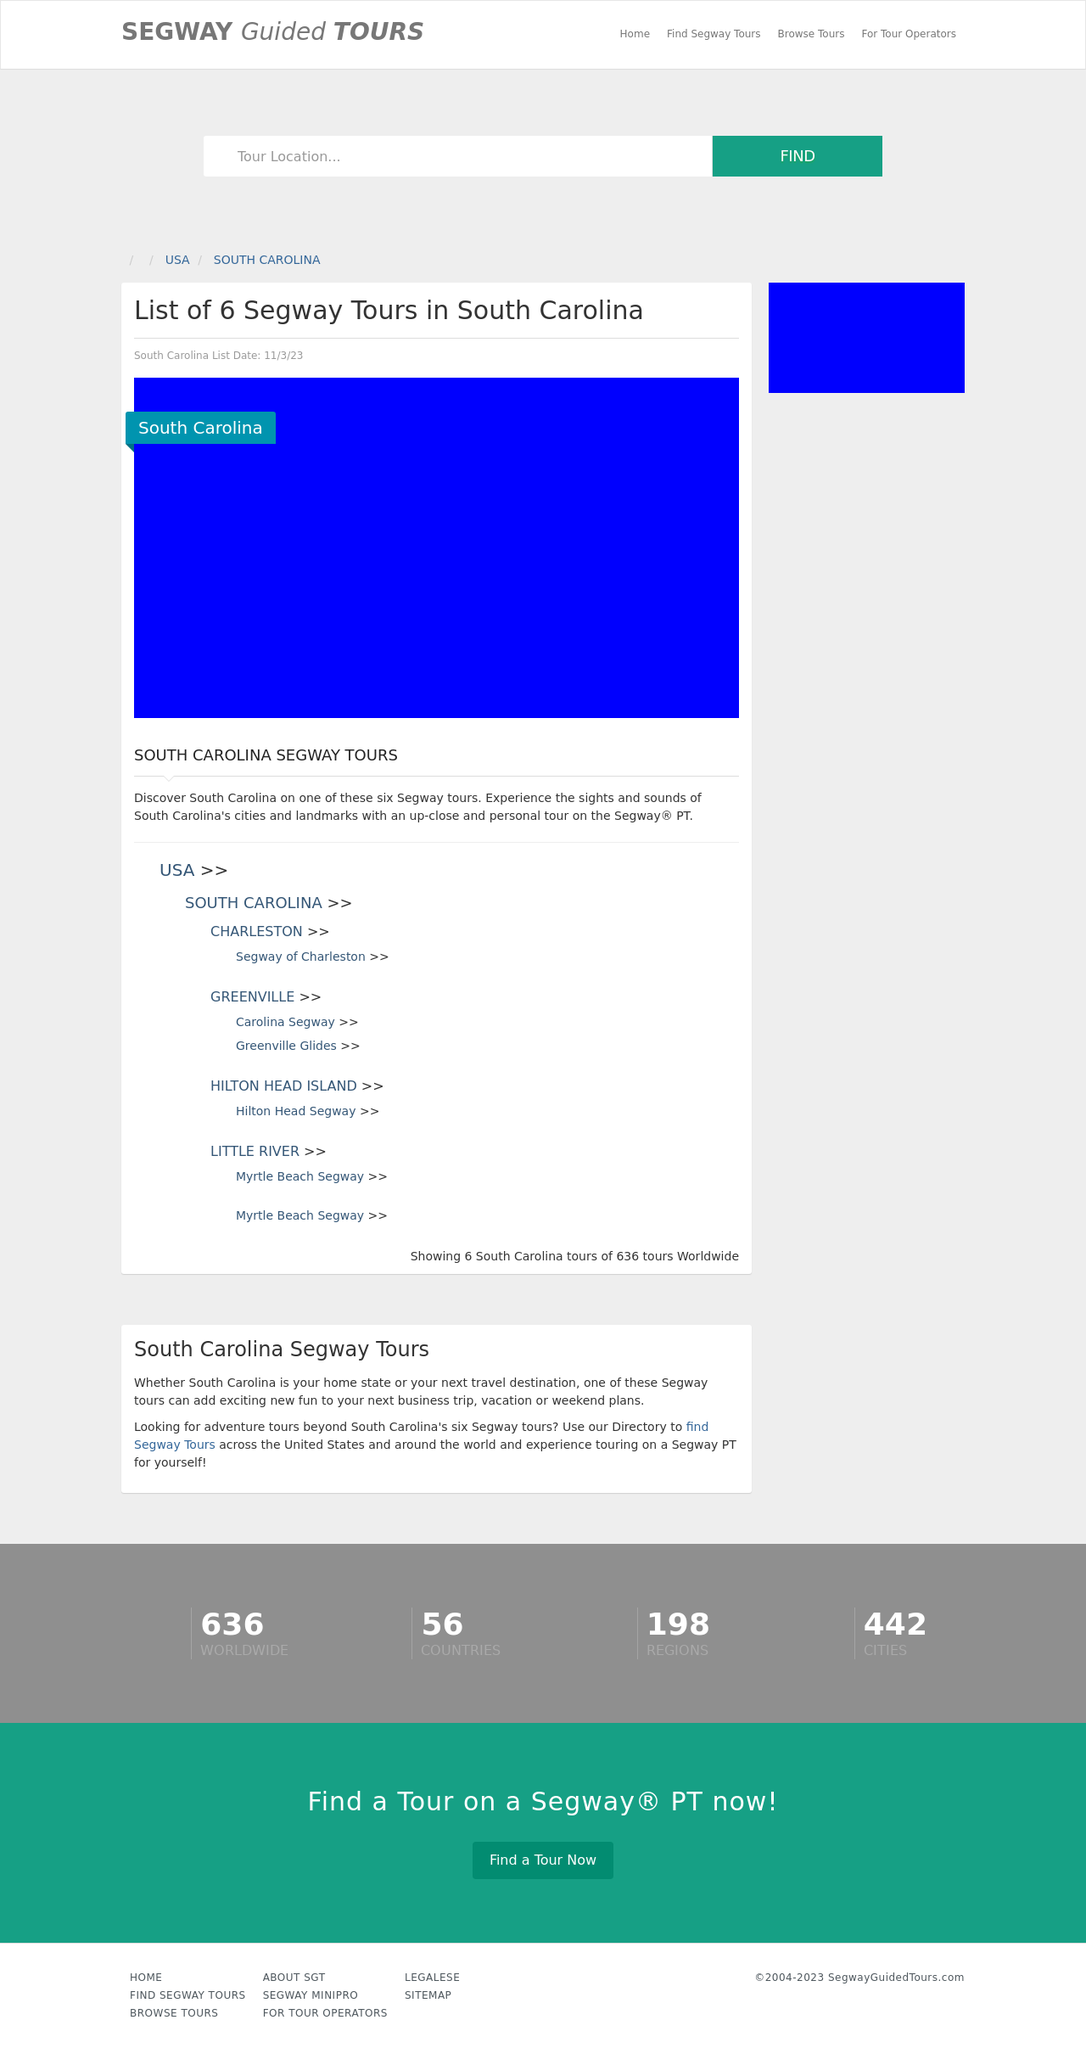Could you detail the process for assembling this website using HTML? Creating a website similar to the one shown in the image, which lists Segway tours in South Carolina, involves several steps using HTML and other web technologies. Here's a simplified process:

1. **Structure with HTML**: Use HTML to define the structure of the webpage. This includes creating the layout with elements like <header>, <nav>, <section>, and <footer> to delineate different parts of the page.
2. **Style with CSS**: Apply CSS for styling the website. This might include setting fonts, colors, and layout styles to make the website visually appealing.
3. **Add Interactivity with JavaScript**: Enhance user interaction by using JavaScript for tasks such as handling the tour search or interactive maps.
4. **Content Management**: Use a server-side language or a content management system to manage and display dynamic content such as the list of tours, which can change frequently.

Understanding web development basics and tools will be essential to successfully create and maintain a functional and attractive tourism website. 